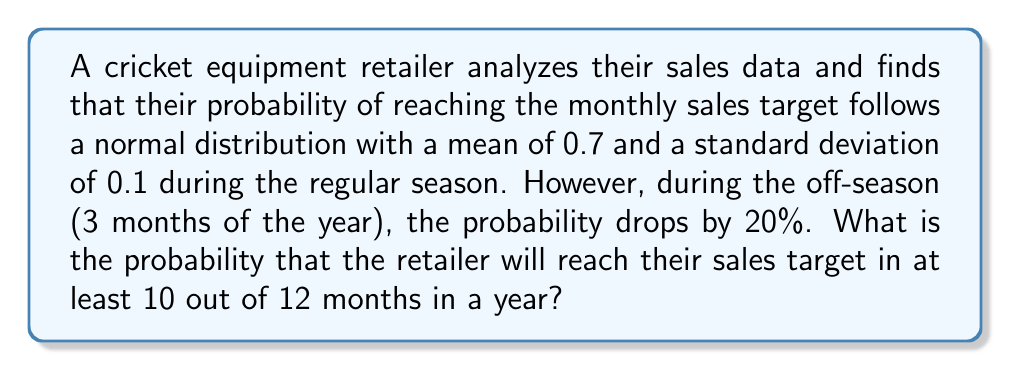What is the answer to this math problem? Let's approach this step-by-step:

1) First, we need to calculate the probability of reaching the sales target for each type of month:

   Regular season (9 months): $p_1 = 0.7$
   Off-season (3 months): $p_2 = 0.7 - (0.7 * 0.2) = 0.56$

2) Now, we can model this as a binomial distribution with 12 trials, where success is reaching the sales target. However, the probability of success varies depending on the month.

3) To solve this, we can use the concept of conditional probability. Let's define events:
   A: Reach target in at least 10 out of 12 months
   B: Reach target in x out of 9 regular months
   C: Reach target in y out of 3 off-season months

4) We need to sum the probabilities for all combinations where x + y ≥ 10:

   $$P(A) = \sum_{x=7}^9 \sum_{y=10-x}^3 P(B) * P(C)$$

5) For each combination:
   $$P(B) = \binom{9}{x} * 0.7^x * 0.3^{9-x}$$
   $$P(C) = \binom{3}{y} * 0.56^y * 0.44^{3-y}$$

6) Calculating each combination:
   x=9, y=1: $\binom{9}{9} * 0.7^9 * 0.3^0 * \binom{3}{1} * 0.56^1 * 0.44^2 = 0.0403$
   x=9, y=0: $\binom{9}{9} * 0.7^9 * 0.3^0 * \binom{3}{0} * 0.56^0 * 0.44^3 = 0.0317$
   x=8, y=2: $\binom{9}{8} * 0.7^8 * 0.3^1 * \binom{3}{2} * 0.56^2 * 0.44^1 = 0.0519$
   x=8, y=1: $\binom{9}{8} * 0.7^8 * 0.3^1 * \binom{3}{1} * 0.56^1 * 0.44^2 = 0.1222$
   x=7, y=3: $\binom{9}{7} * 0.7^7 * 0.3^2 * \binom{3}{3} * 0.56^3 * 0.44^0 = 0.0067$
   x=7, y=2: $\binom{9}{7} * 0.7^7 * 0.3^2 * \binom{3}{2} * 0.56^2 * 0.44^1 = 0.0474$

7) Sum all these probabilities:

   $$P(A) = 0.0403 + 0.0317 + 0.0519 + 0.1222 + 0.0067 + 0.0474 = 0.3002$$
Answer: 0.3002 